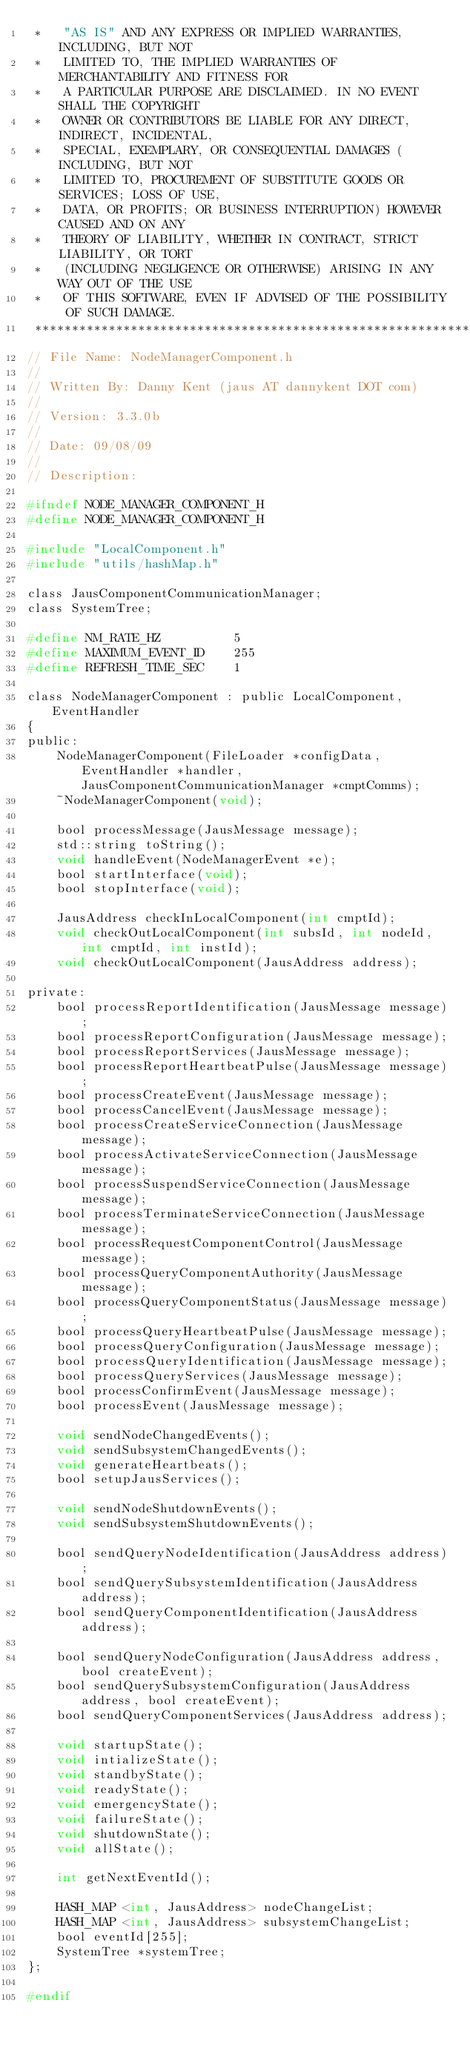Convert code to text. <code><loc_0><loc_0><loc_500><loc_500><_C_> *   "AS IS" AND ANY EXPRESS OR IMPLIED WARRANTIES, INCLUDING, BUT NOT
 *   LIMITED TO, THE IMPLIED WARRANTIES OF MERCHANTABILITY AND FITNESS FOR
 *   A PARTICULAR PURPOSE ARE DISCLAIMED. IN NO EVENT SHALL THE COPYRIGHT
 *   OWNER OR CONTRIBUTORS BE LIABLE FOR ANY DIRECT, INDIRECT, INCIDENTAL,
 *   SPECIAL, EXEMPLARY, OR CONSEQUENTIAL DAMAGES (INCLUDING, BUT NOT
 *   LIMITED TO, PROCUREMENT OF SUBSTITUTE GOODS OR SERVICES; LOSS OF USE,
 *   DATA, OR PROFITS; OR BUSINESS INTERRUPTION) HOWEVER CAUSED AND ON ANY
 *   THEORY OF LIABILITY, WHETHER IN CONTRACT, STRICT LIABILITY, OR TORT
 *   (INCLUDING NEGLIGENCE OR OTHERWISE) ARISING IN ANY WAY OUT OF THE USE
 *   OF THIS SOFTWARE, EVEN IF ADVISED OF THE POSSIBILITY OF SUCH DAMAGE.
 ****************************************************************************/
// File Name: NodeManagerComponent.h
//
// Written By: Danny Kent (jaus AT dannykent DOT com)
//
// Version: 3.3.0b
//
// Date: 09/08/09
//
// Description:

#ifndef NODE_MANAGER_COMPONENT_H
#define NODE_MANAGER_COMPONENT_H

#include "LocalComponent.h"
#include "utils/hashMap.h"

class JausComponentCommunicationManager;
class SystemTree;

#define NM_RATE_HZ			5
#define MAXIMUM_EVENT_ID	255
#define REFRESH_TIME_SEC	1

class NodeManagerComponent : public LocalComponent, EventHandler
{
public:
	NodeManagerComponent(FileLoader *configData, EventHandler *handler, JausComponentCommunicationManager *cmptComms);
	~NodeManagerComponent(void);

	bool processMessage(JausMessage message);
	std::string toString();
	void handleEvent(NodeManagerEvent *e);
	bool startInterface(void);
	bool stopInterface(void);

	JausAddress checkInLocalComponent(int cmptId);
	void checkOutLocalComponent(int subsId, int nodeId, int cmptId, int instId);
	void checkOutLocalComponent(JausAddress address);

private:
	bool processReportIdentification(JausMessage message);
	bool processReportConfiguration(JausMessage message);
	bool processReportServices(JausMessage message);
	bool processReportHeartbeatPulse(JausMessage message);
	bool processCreateEvent(JausMessage message);
	bool processCancelEvent(JausMessage message);
	bool processCreateServiceConnection(JausMessage message);
	bool processActivateServiceConnection(JausMessage message);
	bool processSuspendServiceConnection(JausMessage message);
	bool processTerminateServiceConnection(JausMessage message);
	bool processRequestComponentControl(JausMessage message);
	bool processQueryComponentAuthority(JausMessage message);
	bool processQueryComponentStatus(JausMessage message);
	bool processQueryHeartbeatPulse(JausMessage message);
	bool processQueryConfiguration(JausMessage message);
	bool processQueryIdentification(JausMessage message);
	bool processQueryServices(JausMessage message);
	bool processConfirmEvent(JausMessage message);
	bool processEvent(JausMessage message);

	void sendNodeChangedEvents();
	void sendSubsystemChangedEvents();
	void generateHeartbeats();
	bool setupJausServices();

	void sendNodeShutdownEvents();
	void sendSubsystemShutdownEvents();

	bool sendQueryNodeIdentification(JausAddress address);
	bool sendQuerySubsystemIdentification(JausAddress address);
	bool sendQueryComponentIdentification(JausAddress address);

	bool sendQueryNodeConfiguration(JausAddress address, bool createEvent);
	bool sendQuerySubsystemConfiguration(JausAddress address, bool createEvent);
	bool sendQueryComponentServices(JausAddress address);

	void startupState();
	void intializeState();
	void standbyState();
	void readyState();
	void emergencyState();
	void failureState();
	void shutdownState();
	void allState();

	int getNextEventId();

	HASH_MAP <int, JausAddress> nodeChangeList;
	HASH_MAP <int, JausAddress> subsystemChangeList;
	bool eventId[255];
	SystemTree *systemTree;
};

#endif
</code> 